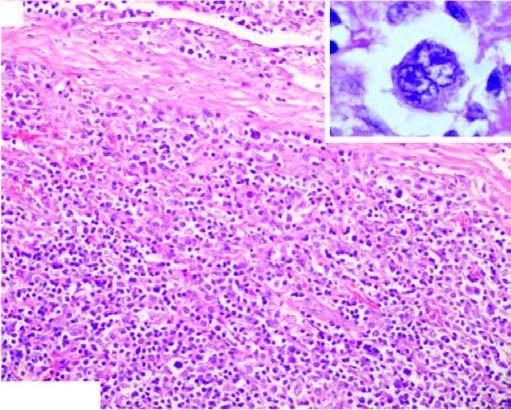s there admixture of mature lymphocytes, plasma cells, neutrophils and eosinophils and classic rs cells in the centre of the field inbox in right figure?
Answer the question using a single word or phrase. Yes 